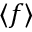Convert formula to latex. <formula><loc_0><loc_0><loc_500><loc_500>\langle f \rangle</formula> 